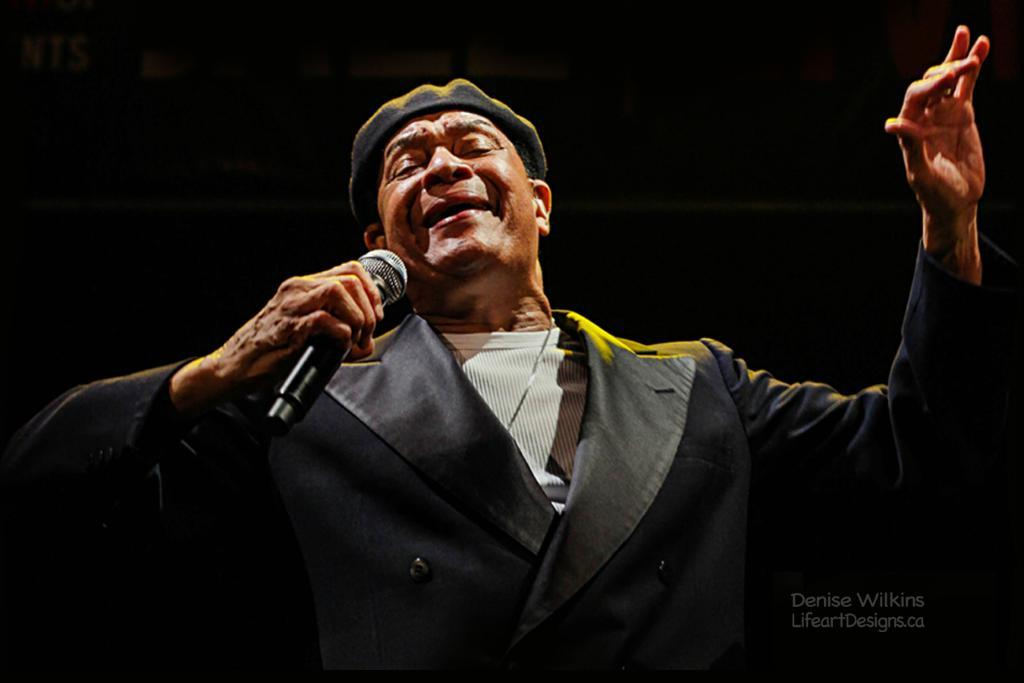What is the main subject of the image? There is a person in the center of the image. What is the person wearing? The person is wearing a cap and a coat. What is the person holding in the image? The person is holding a mic. What can be seen at the bottom of the image? There is some text at the bottom of the image. How would you describe the background of the image? The background of the image is dark. What type of jam is being spread on the wall in the image? There is no jam or wall present in the image; it features a person wearing a cap, coat, and holding a mic. 